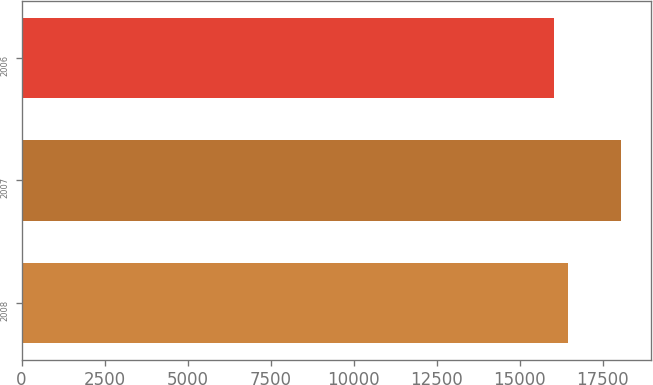<chart> <loc_0><loc_0><loc_500><loc_500><bar_chart><fcel>2008<fcel>2007<fcel>2006<nl><fcel>16468<fcel>18052<fcel>16022<nl></chart> 